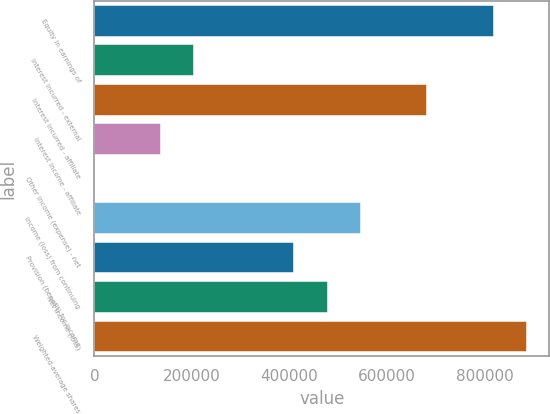Convert chart to OTSL. <chart><loc_0><loc_0><loc_500><loc_500><bar_chart><fcel>Equity in earnings of<fcel>Interest incurred - external<fcel>Interest incurred - affiliate<fcel>Interest income - affiliate<fcel>Other income (expense) - net<fcel>Income (loss) from continuing<fcel>Provision (benefit) for income<fcel>Net income (loss)<fcel>Weighted-average shares<nl><fcel>819531<fcel>204907<fcel>682948<fcel>136615<fcel>32<fcel>546365<fcel>409782<fcel>478073<fcel>887823<nl></chart> 